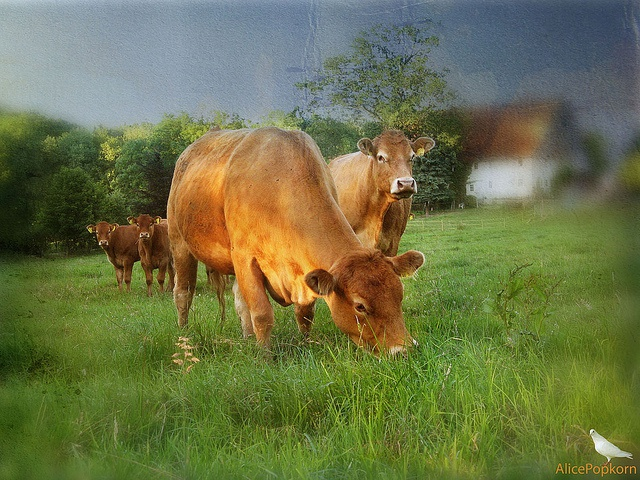Describe the objects in this image and their specific colors. I can see cow in lightgray, brown, orange, and maroon tones, cow in lightgray, brown, tan, and maroon tones, cow in lightgray, maroon, black, and brown tones, and cow in lightgray, maroon, olive, black, and brown tones in this image. 